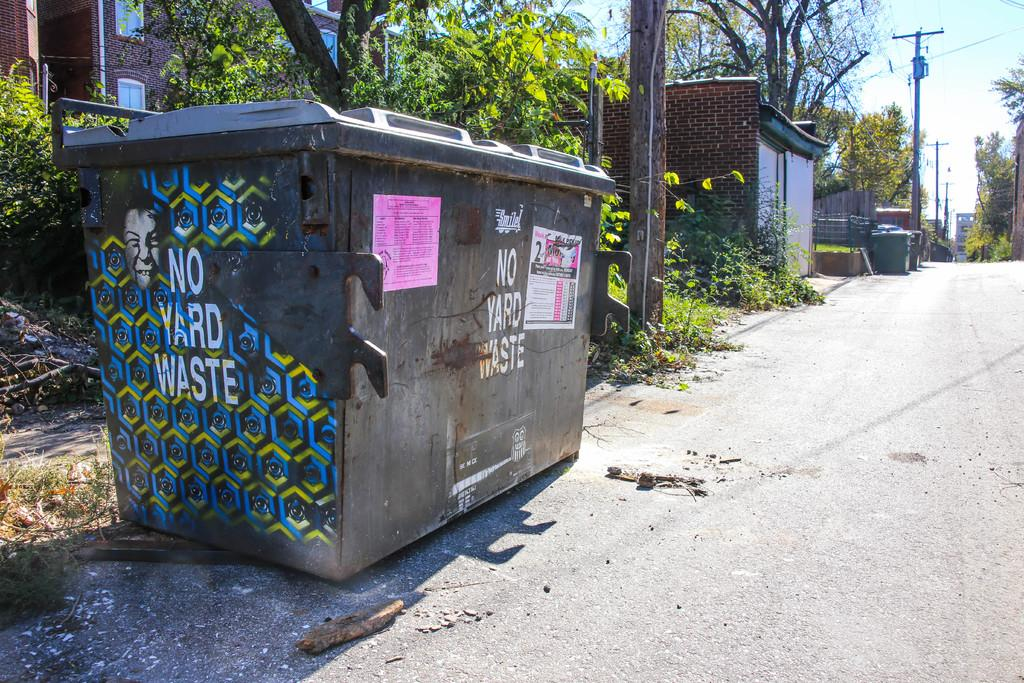<image>
Render a clear and concise summary of the photo. A large trash bin says "NO YARD WASTE" on the front and side. 